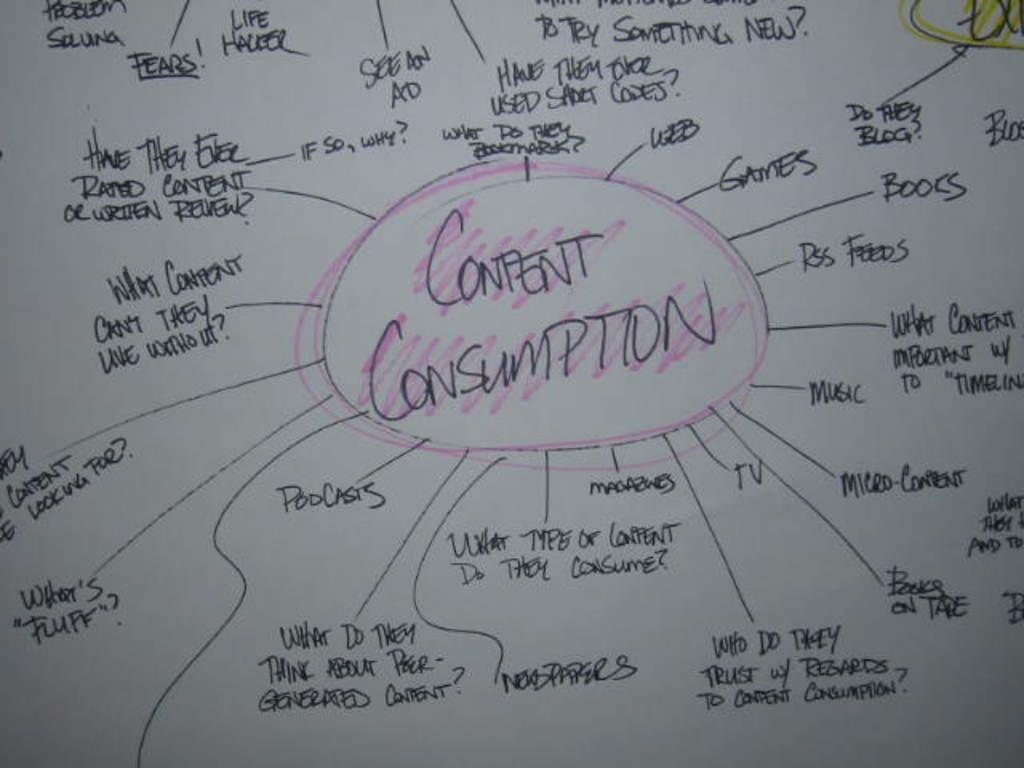What is the main object in the image? There is a white color board in the image. What is on the color board? There are writings on the board. What colors were used to create the writings on the board? The writings are made with black, pink, and yellow color markers. Can you see a branch on fire in the image? No, there is no branch or fire present in the image. Is there a drum being played in the image? No, there is no drum or indication of music being played in the image. 